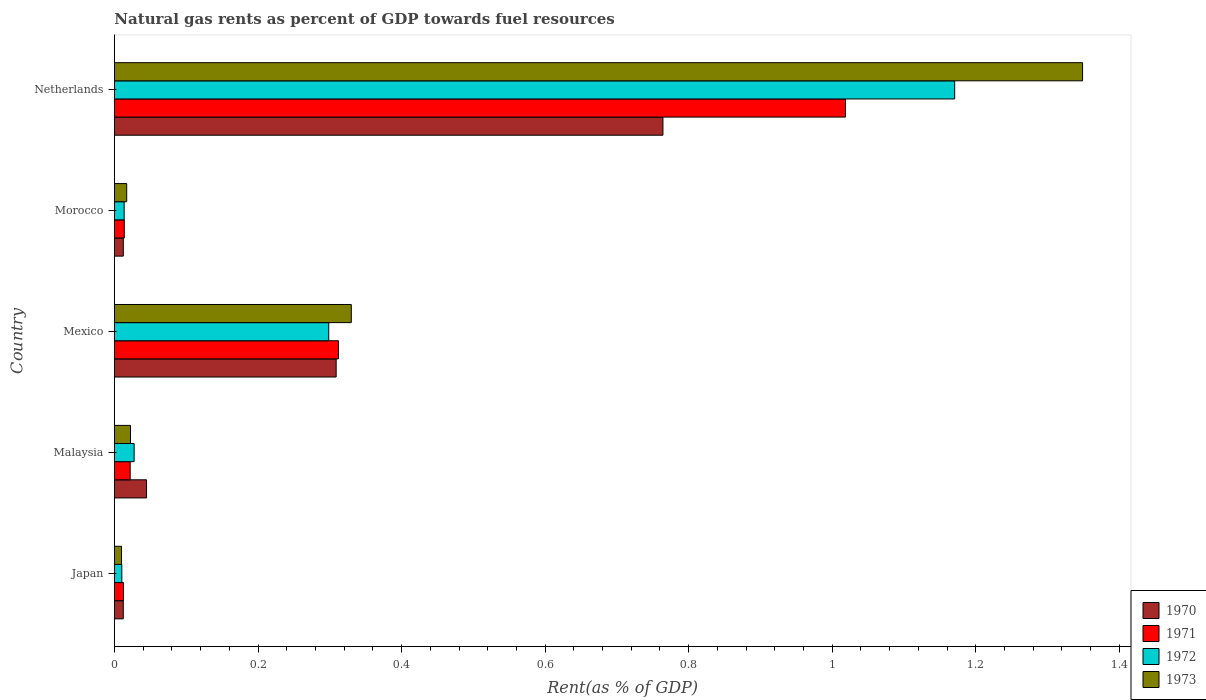How many different coloured bars are there?
Ensure brevity in your answer.  4. How many groups of bars are there?
Provide a succinct answer. 5. Are the number of bars on each tick of the Y-axis equal?
Keep it short and to the point. Yes. How many bars are there on the 2nd tick from the top?
Your answer should be very brief. 4. How many bars are there on the 5th tick from the bottom?
Give a very brief answer. 4. What is the label of the 2nd group of bars from the top?
Your answer should be very brief. Morocco. In how many cases, is the number of bars for a given country not equal to the number of legend labels?
Your response must be concise. 0. What is the matural gas rent in 1973 in Netherlands?
Your answer should be very brief. 1.35. Across all countries, what is the maximum matural gas rent in 1973?
Ensure brevity in your answer.  1.35. Across all countries, what is the minimum matural gas rent in 1973?
Your answer should be very brief. 0.01. In which country was the matural gas rent in 1971 minimum?
Provide a succinct answer. Japan. What is the total matural gas rent in 1973 in the graph?
Make the answer very short. 1.73. What is the difference between the matural gas rent in 1973 in Malaysia and that in Morocco?
Give a very brief answer. 0.01. What is the difference between the matural gas rent in 1972 in Morocco and the matural gas rent in 1973 in Malaysia?
Give a very brief answer. -0.01. What is the average matural gas rent in 1971 per country?
Your response must be concise. 0.28. What is the difference between the matural gas rent in 1971 and matural gas rent in 1973 in Morocco?
Your answer should be compact. -0. What is the ratio of the matural gas rent in 1970 in Japan to that in Morocco?
Offer a very short reply. 1. What is the difference between the highest and the second highest matural gas rent in 1970?
Offer a terse response. 0.46. What is the difference between the highest and the lowest matural gas rent in 1971?
Your answer should be very brief. 1.01. In how many countries, is the matural gas rent in 1972 greater than the average matural gas rent in 1972 taken over all countries?
Keep it short and to the point. 1. Is the sum of the matural gas rent in 1970 in Japan and Malaysia greater than the maximum matural gas rent in 1972 across all countries?
Offer a very short reply. No. What does the 3rd bar from the bottom in Japan represents?
Keep it short and to the point. 1972. Are all the bars in the graph horizontal?
Offer a very short reply. Yes. Does the graph contain any zero values?
Your answer should be compact. No. Does the graph contain grids?
Offer a very short reply. No. Where does the legend appear in the graph?
Provide a succinct answer. Bottom right. What is the title of the graph?
Give a very brief answer. Natural gas rents as percent of GDP towards fuel resources. What is the label or title of the X-axis?
Offer a terse response. Rent(as % of GDP). What is the Rent(as % of GDP) of 1970 in Japan?
Provide a short and direct response. 0.01. What is the Rent(as % of GDP) in 1971 in Japan?
Ensure brevity in your answer.  0.01. What is the Rent(as % of GDP) in 1972 in Japan?
Give a very brief answer. 0.01. What is the Rent(as % of GDP) of 1973 in Japan?
Your answer should be compact. 0.01. What is the Rent(as % of GDP) of 1970 in Malaysia?
Provide a short and direct response. 0.04. What is the Rent(as % of GDP) in 1971 in Malaysia?
Keep it short and to the point. 0.02. What is the Rent(as % of GDP) of 1972 in Malaysia?
Provide a short and direct response. 0.03. What is the Rent(as % of GDP) of 1973 in Malaysia?
Your response must be concise. 0.02. What is the Rent(as % of GDP) of 1970 in Mexico?
Make the answer very short. 0.31. What is the Rent(as % of GDP) of 1971 in Mexico?
Your answer should be compact. 0.31. What is the Rent(as % of GDP) in 1972 in Mexico?
Give a very brief answer. 0.3. What is the Rent(as % of GDP) of 1973 in Mexico?
Keep it short and to the point. 0.33. What is the Rent(as % of GDP) of 1970 in Morocco?
Your answer should be very brief. 0.01. What is the Rent(as % of GDP) of 1971 in Morocco?
Provide a short and direct response. 0.01. What is the Rent(as % of GDP) of 1972 in Morocco?
Offer a terse response. 0.01. What is the Rent(as % of GDP) of 1973 in Morocco?
Offer a very short reply. 0.02. What is the Rent(as % of GDP) in 1970 in Netherlands?
Offer a terse response. 0.76. What is the Rent(as % of GDP) in 1971 in Netherlands?
Ensure brevity in your answer.  1.02. What is the Rent(as % of GDP) of 1972 in Netherlands?
Provide a succinct answer. 1.17. What is the Rent(as % of GDP) of 1973 in Netherlands?
Make the answer very short. 1.35. Across all countries, what is the maximum Rent(as % of GDP) in 1970?
Offer a very short reply. 0.76. Across all countries, what is the maximum Rent(as % of GDP) of 1971?
Your response must be concise. 1.02. Across all countries, what is the maximum Rent(as % of GDP) of 1972?
Provide a succinct answer. 1.17. Across all countries, what is the maximum Rent(as % of GDP) of 1973?
Your answer should be very brief. 1.35. Across all countries, what is the minimum Rent(as % of GDP) of 1970?
Offer a very short reply. 0.01. Across all countries, what is the minimum Rent(as % of GDP) of 1971?
Offer a very short reply. 0.01. Across all countries, what is the minimum Rent(as % of GDP) of 1972?
Make the answer very short. 0.01. Across all countries, what is the minimum Rent(as % of GDP) in 1973?
Your answer should be compact. 0.01. What is the total Rent(as % of GDP) in 1970 in the graph?
Provide a short and direct response. 1.14. What is the total Rent(as % of GDP) of 1971 in the graph?
Keep it short and to the point. 1.38. What is the total Rent(as % of GDP) of 1972 in the graph?
Keep it short and to the point. 1.52. What is the total Rent(as % of GDP) of 1973 in the graph?
Your answer should be very brief. 1.73. What is the difference between the Rent(as % of GDP) of 1970 in Japan and that in Malaysia?
Offer a terse response. -0.03. What is the difference between the Rent(as % of GDP) in 1971 in Japan and that in Malaysia?
Provide a succinct answer. -0.01. What is the difference between the Rent(as % of GDP) in 1972 in Japan and that in Malaysia?
Ensure brevity in your answer.  -0.02. What is the difference between the Rent(as % of GDP) in 1973 in Japan and that in Malaysia?
Provide a succinct answer. -0.01. What is the difference between the Rent(as % of GDP) of 1970 in Japan and that in Mexico?
Give a very brief answer. -0.3. What is the difference between the Rent(as % of GDP) of 1971 in Japan and that in Mexico?
Provide a succinct answer. -0.3. What is the difference between the Rent(as % of GDP) of 1972 in Japan and that in Mexico?
Make the answer very short. -0.29. What is the difference between the Rent(as % of GDP) in 1973 in Japan and that in Mexico?
Make the answer very short. -0.32. What is the difference between the Rent(as % of GDP) of 1971 in Japan and that in Morocco?
Make the answer very short. -0. What is the difference between the Rent(as % of GDP) of 1972 in Japan and that in Morocco?
Give a very brief answer. -0. What is the difference between the Rent(as % of GDP) of 1973 in Japan and that in Morocco?
Your answer should be very brief. -0.01. What is the difference between the Rent(as % of GDP) in 1970 in Japan and that in Netherlands?
Offer a very short reply. -0.75. What is the difference between the Rent(as % of GDP) in 1971 in Japan and that in Netherlands?
Your answer should be very brief. -1.01. What is the difference between the Rent(as % of GDP) of 1972 in Japan and that in Netherlands?
Make the answer very short. -1.16. What is the difference between the Rent(as % of GDP) in 1973 in Japan and that in Netherlands?
Offer a terse response. -1.34. What is the difference between the Rent(as % of GDP) in 1970 in Malaysia and that in Mexico?
Provide a short and direct response. -0.26. What is the difference between the Rent(as % of GDP) in 1971 in Malaysia and that in Mexico?
Offer a terse response. -0.29. What is the difference between the Rent(as % of GDP) in 1972 in Malaysia and that in Mexico?
Your answer should be compact. -0.27. What is the difference between the Rent(as % of GDP) of 1973 in Malaysia and that in Mexico?
Give a very brief answer. -0.31. What is the difference between the Rent(as % of GDP) in 1970 in Malaysia and that in Morocco?
Keep it short and to the point. 0.03. What is the difference between the Rent(as % of GDP) in 1971 in Malaysia and that in Morocco?
Keep it short and to the point. 0.01. What is the difference between the Rent(as % of GDP) of 1972 in Malaysia and that in Morocco?
Keep it short and to the point. 0.01. What is the difference between the Rent(as % of GDP) in 1973 in Malaysia and that in Morocco?
Offer a terse response. 0.01. What is the difference between the Rent(as % of GDP) of 1970 in Malaysia and that in Netherlands?
Offer a terse response. -0.72. What is the difference between the Rent(as % of GDP) of 1971 in Malaysia and that in Netherlands?
Give a very brief answer. -1. What is the difference between the Rent(as % of GDP) of 1972 in Malaysia and that in Netherlands?
Give a very brief answer. -1.14. What is the difference between the Rent(as % of GDP) in 1973 in Malaysia and that in Netherlands?
Ensure brevity in your answer.  -1.33. What is the difference between the Rent(as % of GDP) in 1970 in Mexico and that in Morocco?
Provide a succinct answer. 0.3. What is the difference between the Rent(as % of GDP) of 1971 in Mexico and that in Morocco?
Provide a short and direct response. 0.3. What is the difference between the Rent(as % of GDP) in 1972 in Mexico and that in Morocco?
Ensure brevity in your answer.  0.28. What is the difference between the Rent(as % of GDP) of 1973 in Mexico and that in Morocco?
Offer a terse response. 0.31. What is the difference between the Rent(as % of GDP) in 1970 in Mexico and that in Netherlands?
Ensure brevity in your answer.  -0.46. What is the difference between the Rent(as % of GDP) in 1971 in Mexico and that in Netherlands?
Keep it short and to the point. -0.71. What is the difference between the Rent(as % of GDP) of 1972 in Mexico and that in Netherlands?
Make the answer very short. -0.87. What is the difference between the Rent(as % of GDP) in 1973 in Mexico and that in Netherlands?
Provide a short and direct response. -1.02. What is the difference between the Rent(as % of GDP) of 1970 in Morocco and that in Netherlands?
Your answer should be very brief. -0.75. What is the difference between the Rent(as % of GDP) of 1971 in Morocco and that in Netherlands?
Make the answer very short. -1. What is the difference between the Rent(as % of GDP) of 1972 in Morocco and that in Netherlands?
Your response must be concise. -1.16. What is the difference between the Rent(as % of GDP) of 1973 in Morocco and that in Netherlands?
Provide a short and direct response. -1.33. What is the difference between the Rent(as % of GDP) in 1970 in Japan and the Rent(as % of GDP) in 1971 in Malaysia?
Give a very brief answer. -0.01. What is the difference between the Rent(as % of GDP) in 1970 in Japan and the Rent(as % of GDP) in 1972 in Malaysia?
Ensure brevity in your answer.  -0.02. What is the difference between the Rent(as % of GDP) of 1970 in Japan and the Rent(as % of GDP) of 1973 in Malaysia?
Your answer should be compact. -0.01. What is the difference between the Rent(as % of GDP) in 1971 in Japan and the Rent(as % of GDP) in 1972 in Malaysia?
Your answer should be very brief. -0.01. What is the difference between the Rent(as % of GDP) in 1971 in Japan and the Rent(as % of GDP) in 1973 in Malaysia?
Keep it short and to the point. -0.01. What is the difference between the Rent(as % of GDP) in 1972 in Japan and the Rent(as % of GDP) in 1973 in Malaysia?
Your answer should be very brief. -0.01. What is the difference between the Rent(as % of GDP) of 1970 in Japan and the Rent(as % of GDP) of 1971 in Mexico?
Give a very brief answer. -0.3. What is the difference between the Rent(as % of GDP) in 1970 in Japan and the Rent(as % of GDP) in 1972 in Mexico?
Give a very brief answer. -0.29. What is the difference between the Rent(as % of GDP) in 1970 in Japan and the Rent(as % of GDP) in 1973 in Mexico?
Offer a very short reply. -0.32. What is the difference between the Rent(as % of GDP) in 1971 in Japan and the Rent(as % of GDP) in 1972 in Mexico?
Make the answer very short. -0.29. What is the difference between the Rent(as % of GDP) in 1971 in Japan and the Rent(as % of GDP) in 1973 in Mexico?
Your answer should be very brief. -0.32. What is the difference between the Rent(as % of GDP) in 1972 in Japan and the Rent(as % of GDP) in 1973 in Mexico?
Make the answer very short. -0.32. What is the difference between the Rent(as % of GDP) of 1970 in Japan and the Rent(as % of GDP) of 1971 in Morocco?
Give a very brief answer. -0. What is the difference between the Rent(as % of GDP) of 1970 in Japan and the Rent(as % of GDP) of 1972 in Morocco?
Your answer should be very brief. -0. What is the difference between the Rent(as % of GDP) in 1970 in Japan and the Rent(as % of GDP) in 1973 in Morocco?
Ensure brevity in your answer.  -0. What is the difference between the Rent(as % of GDP) in 1971 in Japan and the Rent(as % of GDP) in 1972 in Morocco?
Your answer should be compact. -0. What is the difference between the Rent(as % of GDP) of 1971 in Japan and the Rent(as % of GDP) of 1973 in Morocco?
Make the answer very short. -0. What is the difference between the Rent(as % of GDP) in 1972 in Japan and the Rent(as % of GDP) in 1973 in Morocco?
Offer a terse response. -0.01. What is the difference between the Rent(as % of GDP) in 1970 in Japan and the Rent(as % of GDP) in 1971 in Netherlands?
Give a very brief answer. -1.01. What is the difference between the Rent(as % of GDP) in 1970 in Japan and the Rent(as % of GDP) in 1972 in Netherlands?
Offer a very short reply. -1.16. What is the difference between the Rent(as % of GDP) in 1970 in Japan and the Rent(as % of GDP) in 1973 in Netherlands?
Give a very brief answer. -1.34. What is the difference between the Rent(as % of GDP) of 1971 in Japan and the Rent(as % of GDP) of 1972 in Netherlands?
Keep it short and to the point. -1.16. What is the difference between the Rent(as % of GDP) in 1971 in Japan and the Rent(as % of GDP) in 1973 in Netherlands?
Make the answer very short. -1.34. What is the difference between the Rent(as % of GDP) in 1972 in Japan and the Rent(as % of GDP) in 1973 in Netherlands?
Your response must be concise. -1.34. What is the difference between the Rent(as % of GDP) of 1970 in Malaysia and the Rent(as % of GDP) of 1971 in Mexico?
Offer a very short reply. -0.27. What is the difference between the Rent(as % of GDP) of 1970 in Malaysia and the Rent(as % of GDP) of 1972 in Mexico?
Make the answer very short. -0.25. What is the difference between the Rent(as % of GDP) of 1970 in Malaysia and the Rent(as % of GDP) of 1973 in Mexico?
Your answer should be compact. -0.29. What is the difference between the Rent(as % of GDP) in 1971 in Malaysia and the Rent(as % of GDP) in 1972 in Mexico?
Provide a short and direct response. -0.28. What is the difference between the Rent(as % of GDP) of 1971 in Malaysia and the Rent(as % of GDP) of 1973 in Mexico?
Your answer should be compact. -0.31. What is the difference between the Rent(as % of GDP) in 1972 in Malaysia and the Rent(as % of GDP) in 1973 in Mexico?
Your response must be concise. -0.3. What is the difference between the Rent(as % of GDP) of 1970 in Malaysia and the Rent(as % of GDP) of 1971 in Morocco?
Ensure brevity in your answer.  0.03. What is the difference between the Rent(as % of GDP) in 1970 in Malaysia and the Rent(as % of GDP) in 1972 in Morocco?
Provide a short and direct response. 0.03. What is the difference between the Rent(as % of GDP) in 1970 in Malaysia and the Rent(as % of GDP) in 1973 in Morocco?
Your answer should be compact. 0.03. What is the difference between the Rent(as % of GDP) of 1971 in Malaysia and the Rent(as % of GDP) of 1972 in Morocco?
Keep it short and to the point. 0.01. What is the difference between the Rent(as % of GDP) of 1971 in Malaysia and the Rent(as % of GDP) of 1973 in Morocco?
Offer a terse response. 0. What is the difference between the Rent(as % of GDP) in 1972 in Malaysia and the Rent(as % of GDP) in 1973 in Morocco?
Your response must be concise. 0.01. What is the difference between the Rent(as % of GDP) in 1970 in Malaysia and the Rent(as % of GDP) in 1971 in Netherlands?
Offer a very short reply. -0.97. What is the difference between the Rent(as % of GDP) in 1970 in Malaysia and the Rent(as % of GDP) in 1972 in Netherlands?
Your response must be concise. -1.13. What is the difference between the Rent(as % of GDP) in 1970 in Malaysia and the Rent(as % of GDP) in 1973 in Netherlands?
Provide a short and direct response. -1.3. What is the difference between the Rent(as % of GDP) in 1971 in Malaysia and the Rent(as % of GDP) in 1972 in Netherlands?
Your response must be concise. -1.15. What is the difference between the Rent(as % of GDP) in 1971 in Malaysia and the Rent(as % of GDP) in 1973 in Netherlands?
Provide a short and direct response. -1.33. What is the difference between the Rent(as % of GDP) in 1972 in Malaysia and the Rent(as % of GDP) in 1973 in Netherlands?
Keep it short and to the point. -1.32. What is the difference between the Rent(as % of GDP) in 1970 in Mexico and the Rent(as % of GDP) in 1971 in Morocco?
Offer a very short reply. 0.3. What is the difference between the Rent(as % of GDP) of 1970 in Mexico and the Rent(as % of GDP) of 1972 in Morocco?
Offer a very short reply. 0.3. What is the difference between the Rent(as % of GDP) of 1970 in Mexico and the Rent(as % of GDP) of 1973 in Morocco?
Offer a terse response. 0.29. What is the difference between the Rent(as % of GDP) of 1971 in Mexico and the Rent(as % of GDP) of 1972 in Morocco?
Your answer should be very brief. 0.3. What is the difference between the Rent(as % of GDP) in 1971 in Mexico and the Rent(as % of GDP) in 1973 in Morocco?
Provide a short and direct response. 0.29. What is the difference between the Rent(as % of GDP) in 1972 in Mexico and the Rent(as % of GDP) in 1973 in Morocco?
Ensure brevity in your answer.  0.28. What is the difference between the Rent(as % of GDP) of 1970 in Mexico and the Rent(as % of GDP) of 1971 in Netherlands?
Provide a succinct answer. -0.71. What is the difference between the Rent(as % of GDP) in 1970 in Mexico and the Rent(as % of GDP) in 1972 in Netherlands?
Offer a very short reply. -0.86. What is the difference between the Rent(as % of GDP) in 1970 in Mexico and the Rent(as % of GDP) in 1973 in Netherlands?
Your answer should be very brief. -1.04. What is the difference between the Rent(as % of GDP) in 1971 in Mexico and the Rent(as % of GDP) in 1972 in Netherlands?
Your answer should be very brief. -0.86. What is the difference between the Rent(as % of GDP) in 1971 in Mexico and the Rent(as % of GDP) in 1973 in Netherlands?
Offer a terse response. -1.04. What is the difference between the Rent(as % of GDP) in 1972 in Mexico and the Rent(as % of GDP) in 1973 in Netherlands?
Ensure brevity in your answer.  -1.05. What is the difference between the Rent(as % of GDP) in 1970 in Morocco and the Rent(as % of GDP) in 1971 in Netherlands?
Keep it short and to the point. -1.01. What is the difference between the Rent(as % of GDP) in 1970 in Morocco and the Rent(as % of GDP) in 1972 in Netherlands?
Make the answer very short. -1.16. What is the difference between the Rent(as % of GDP) of 1970 in Morocco and the Rent(as % of GDP) of 1973 in Netherlands?
Ensure brevity in your answer.  -1.34. What is the difference between the Rent(as % of GDP) in 1971 in Morocco and the Rent(as % of GDP) in 1972 in Netherlands?
Give a very brief answer. -1.16. What is the difference between the Rent(as % of GDP) in 1971 in Morocco and the Rent(as % of GDP) in 1973 in Netherlands?
Your answer should be very brief. -1.33. What is the difference between the Rent(as % of GDP) of 1972 in Morocco and the Rent(as % of GDP) of 1973 in Netherlands?
Your answer should be compact. -1.34. What is the average Rent(as % of GDP) of 1970 per country?
Offer a very short reply. 0.23. What is the average Rent(as % of GDP) of 1971 per country?
Your response must be concise. 0.28. What is the average Rent(as % of GDP) of 1972 per country?
Make the answer very short. 0.3. What is the average Rent(as % of GDP) of 1973 per country?
Your answer should be very brief. 0.35. What is the difference between the Rent(as % of GDP) of 1970 and Rent(as % of GDP) of 1971 in Japan?
Keep it short and to the point. -0. What is the difference between the Rent(as % of GDP) of 1970 and Rent(as % of GDP) of 1972 in Japan?
Your answer should be very brief. 0. What is the difference between the Rent(as % of GDP) of 1970 and Rent(as % of GDP) of 1973 in Japan?
Make the answer very short. 0. What is the difference between the Rent(as % of GDP) in 1971 and Rent(as % of GDP) in 1972 in Japan?
Your answer should be compact. 0. What is the difference between the Rent(as % of GDP) of 1971 and Rent(as % of GDP) of 1973 in Japan?
Make the answer very short. 0. What is the difference between the Rent(as % of GDP) of 1972 and Rent(as % of GDP) of 1973 in Japan?
Ensure brevity in your answer.  0. What is the difference between the Rent(as % of GDP) in 1970 and Rent(as % of GDP) in 1971 in Malaysia?
Give a very brief answer. 0.02. What is the difference between the Rent(as % of GDP) of 1970 and Rent(as % of GDP) of 1972 in Malaysia?
Ensure brevity in your answer.  0.02. What is the difference between the Rent(as % of GDP) of 1970 and Rent(as % of GDP) of 1973 in Malaysia?
Your response must be concise. 0.02. What is the difference between the Rent(as % of GDP) of 1971 and Rent(as % of GDP) of 1972 in Malaysia?
Provide a short and direct response. -0.01. What is the difference between the Rent(as % of GDP) in 1971 and Rent(as % of GDP) in 1973 in Malaysia?
Offer a very short reply. -0. What is the difference between the Rent(as % of GDP) of 1972 and Rent(as % of GDP) of 1973 in Malaysia?
Make the answer very short. 0.01. What is the difference between the Rent(as % of GDP) of 1970 and Rent(as % of GDP) of 1971 in Mexico?
Offer a very short reply. -0. What is the difference between the Rent(as % of GDP) in 1970 and Rent(as % of GDP) in 1972 in Mexico?
Provide a short and direct response. 0.01. What is the difference between the Rent(as % of GDP) in 1970 and Rent(as % of GDP) in 1973 in Mexico?
Provide a short and direct response. -0.02. What is the difference between the Rent(as % of GDP) in 1971 and Rent(as % of GDP) in 1972 in Mexico?
Give a very brief answer. 0.01. What is the difference between the Rent(as % of GDP) in 1971 and Rent(as % of GDP) in 1973 in Mexico?
Keep it short and to the point. -0.02. What is the difference between the Rent(as % of GDP) in 1972 and Rent(as % of GDP) in 1973 in Mexico?
Give a very brief answer. -0.03. What is the difference between the Rent(as % of GDP) of 1970 and Rent(as % of GDP) of 1971 in Morocco?
Offer a very short reply. -0. What is the difference between the Rent(as % of GDP) of 1970 and Rent(as % of GDP) of 1972 in Morocco?
Your answer should be very brief. -0. What is the difference between the Rent(as % of GDP) in 1970 and Rent(as % of GDP) in 1973 in Morocco?
Ensure brevity in your answer.  -0. What is the difference between the Rent(as % of GDP) of 1971 and Rent(as % of GDP) of 1973 in Morocco?
Your answer should be compact. -0. What is the difference between the Rent(as % of GDP) in 1972 and Rent(as % of GDP) in 1973 in Morocco?
Offer a terse response. -0. What is the difference between the Rent(as % of GDP) in 1970 and Rent(as % of GDP) in 1971 in Netherlands?
Provide a succinct answer. -0.25. What is the difference between the Rent(as % of GDP) of 1970 and Rent(as % of GDP) of 1972 in Netherlands?
Make the answer very short. -0.41. What is the difference between the Rent(as % of GDP) of 1970 and Rent(as % of GDP) of 1973 in Netherlands?
Ensure brevity in your answer.  -0.58. What is the difference between the Rent(as % of GDP) in 1971 and Rent(as % of GDP) in 1972 in Netherlands?
Offer a very short reply. -0.15. What is the difference between the Rent(as % of GDP) in 1971 and Rent(as % of GDP) in 1973 in Netherlands?
Provide a succinct answer. -0.33. What is the difference between the Rent(as % of GDP) of 1972 and Rent(as % of GDP) of 1973 in Netherlands?
Keep it short and to the point. -0.18. What is the ratio of the Rent(as % of GDP) in 1970 in Japan to that in Malaysia?
Make the answer very short. 0.28. What is the ratio of the Rent(as % of GDP) of 1971 in Japan to that in Malaysia?
Make the answer very short. 0.58. What is the ratio of the Rent(as % of GDP) of 1972 in Japan to that in Malaysia?
Your response must be concise. 0.38. What is the ratio of the Rent(as % of GDP) in 1973 in Japan to that in Malaysia?
Provide a succinct answer. 0.44. What is the ratio of the Rent(as % of GDP) of 1970 in Japan to that in Mexico?
Make the answer very short. 0.04. What is the ratio of the Rent(as % of GDP) of 1971 in Japan to that in Mexico?
Offer a terse response. 0.04. What is the ratio of the Rent(as % of GDP) in 1972 in Japan to that in Mexico?
Your answer should be compact. 0.03. What is the ratio of the Rent(as % of GDP) in 1973 in Japan to that in Mexico?
Keep it short and to the point. 0.03. What is the ratio of the Rent(as % of GDP) of 1970 in Japan to that in Morocco?
Provide a succinct answer. 1. What is the ratio of the Rent(as % of GDP) in 1971 in Japan to that in Morocco?
Offer a very short reply. 0.92. What is the ratio of the Rent(as % of GDP) of 1972 in Japan to that in Morocco?
Make the answer very short. 0.76. What is the ratio of the Rent(as % of GDP) in 1973 in Japan to that in Morocco?
Keep it short and to the point. 0.58. What is the ratio of the Rent(as % of GDP) in 1970 in Japan to that in Netherlands?
Offer a terse response. 0.02. What is the ratio of the Rent(as % of GDP) in 1971 in Japan to that in Netherlands?
Your response must be concise. 0.01. What is the ratio of the Rent(as % of GDP) in 1972 in Japan to that in Netherlands?
Your answer should be very brief. 0.01. What is the ratio of the Rent(as % of GDP) of 1973 in Japan to that in Netherlands?
Make the answer very short. 0.01. What is the ratio of the Rent(as % of GDP) in 1970 in Malaysia to that in Mexico?
Ensure brevity in your answer.  0.14. What is the ratio of the Rent(as % of GDP) of 1971 in Malaysia to that in Mexico?
Offer a very short reply. 0.07. What is the ratio of the Rent(as % of GDP) of 1972 in Malaysia to that in Mexico?
Provide a succinct answer. 0.09. What is the ratio of the Rent(as % of GDP) of 1973 in Malaysia to that in Mexico?
Offer a terse response. 0.07. What is the ratio of the Rent(as % of GDP) in 1970 in Malaysia to that in Morocco?
Provide a succinct answer. 3.62. What is the ratio of the Rent(as % of GDP) of 1971 in Malaysia to that in Morocco?
Make the answer very short. 1.6. What is the ratio of the Rent(as % of GDP) in 1972 in Malaysia to that in Morocco?
Make the answer very short. 2.03. What is the ratio of the Rent(as % of GDP) of 1973 in Malaysia to that in Morocco?
Provide a short and direct response. 1.31. What is the ratio of the Rent(as % of GDP) in 1970 in Malaysia to that in Netherlands?
Your response must be concise. 0.06. What is the ratio of the Rent(as % of GDP) of 1971 in Malaysia to that in Netherlands?
Your response must be concise. 0.02. What is the ratio of the Rent(as % of GDP) in 1972 in Malaysia to that in Netherlands?
Your answer should be compact. 0.02. What is the ratio of the Rent(as % of GDP) in 1973 in Malaysia to that in Netherlands?
Give a very brief answer. 0.02. What is the ratio of the Rent(as % of GDP) of 1970 in Mexico to that in Morocco?
Offer a terse response. 25. What is the ratio of the Rent(as % of GDP) of 1971 in Mexico to that in Morocco?
Give a very brief answer. 22.74. What is the ratio of the Rent(as % of GDP) in 1972 in Mexico to that in Morocco?
Provide a succinct answer. 22.04. What is the ratio of the Rent(as % of GDP) in 1973 in Mexico to that in Morocco?
Offer a terse response. 19.3. What is the ratio of the Rent(as % of GDP) of 1970 in Mexico to that in Netherlands?
Give a very brief answer. 0.4. What is the ratio of the Rent(as % of GDP) in 1971 in Mexico to that in Netherlands?
Keep it short and to the point. 0.31. What is the ratio of the Rent(as % of GDP) of 1972 in Mexico to that in Netherlands?
Keep it short and to the point. 0.26. What is the ratio of the Rent(as % of GDP) in 1973 in Mexico to that in Netherlands?
Ensure brevity in your answer.  0.24. What is the ratio of the Rent(as % of GDP) of 1970 in Morocco to that in Netherlands?
Make the answer very short. 0.02. What is the ratio of the Rent(as % of GDP) of 1971 in Morocco to that in Netherlands?
Your answer should be very brief. 0.01. What is the ratio of the Rent(as % of GDP) in 1972 in Morocco to that in Netherlands?
Keep it short and to the point. 0.01. What is the ratio of the Rent(as % of GDP) of 1973 in Morocco to that in Netherlands?
Make the answer very short. 0.01. What is the difference between the highest and the second highest Rent(as % of GDP) of 1970?
Provide a succinct answer. 0.46. What is the difference between the highest and the second highest Rent(as % of GDP) in 1971?
Provide a short and direct response. 0.71. What is the difference between the highest and the second highest Rent(as % of GDP) in 1972?
Your answer should be compact. 0.87. What is the difference between the highest and the second highest Rent(as % of GDP) of 1973?
Provide a succinct answer. 1.02. What is the difference between the highest and the lowest Rent(as % of GDP) of 1970?
Make the answer very short. 0.75. What is the difference between the highest and the lowest Rent(as % of GDP) of 1971?
Offer a very short reply. 1.01. What is the difference between the highest and the lowest Rent(as % of GDP) in 1972?
Keep it short and to the point. 1.16. What is the difference between the highest and the lowest Rent(as % of GDP) of 1973?
Offer a very short reply. 1.34. 